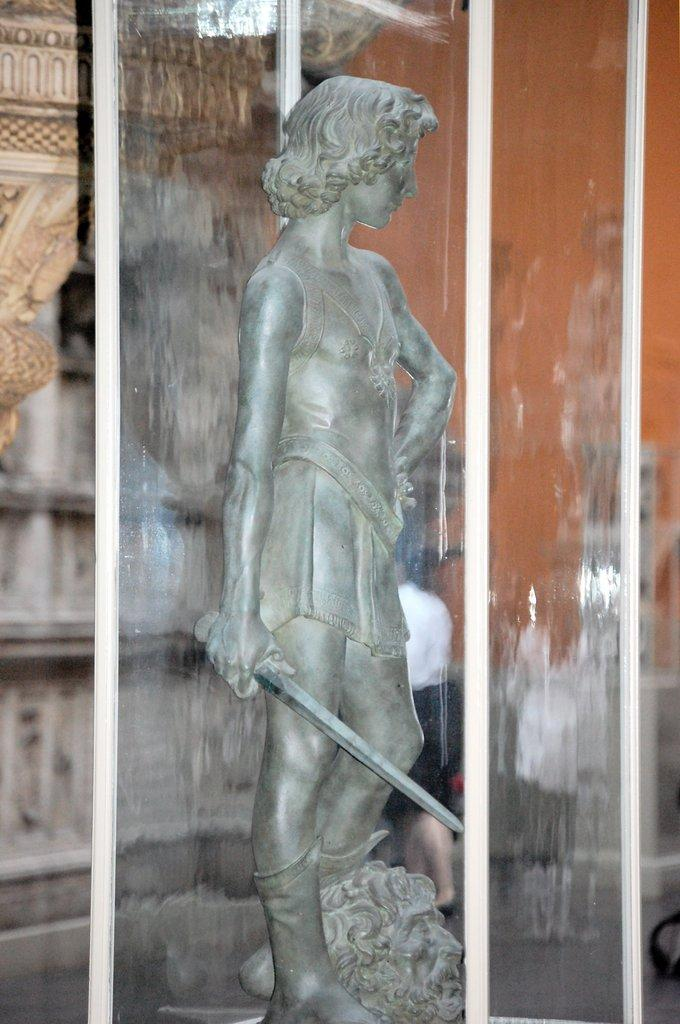What is the main object in the image? There is a glass box in the image. What is inside the glass box? There is a sculpture inside the glass box. What can be seen behind the glass box? There is a wall behind the glass box. What architectural feature is located to the left of the glass box? There is a pillar to the left of the glass box. What type of cabbage is being used to create the sculpture in the image? There is no cabbage present in the image; the sculpture is inside a glass box. How does the grape contribute to the structure of the glass box in the image? There are no grapes present in the image, and they are not related to the structure of the glass box. 